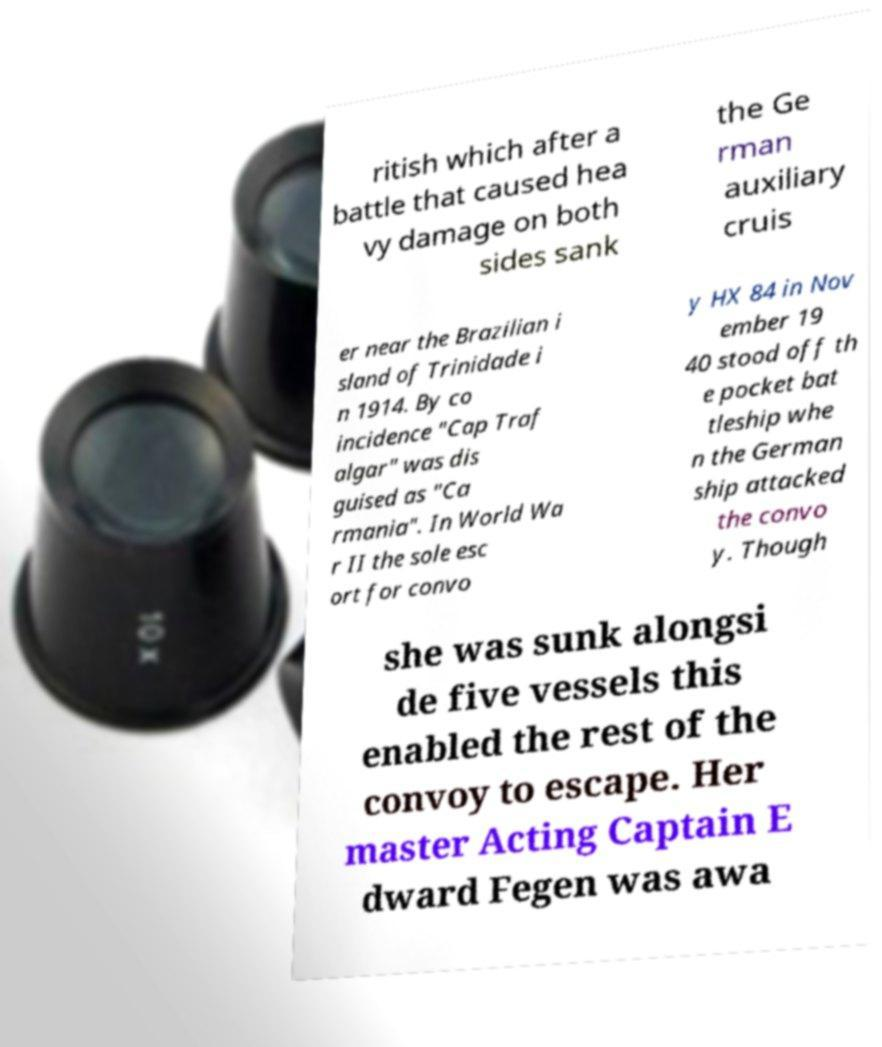Can you accurately transcribe the text from the provided image for me? ritish which after a battle that caused hea vy damage on both sides sank the Ge rman auxiliary cruis er near the Brazilian i sland of Trinidade i n 1914. By co incidence "Cap Traf algar" was dis guised as "Ca rmania". In World Wa r II the sole esc ort for convo y HX 84 in Nov ember 19 40 stood off th e pocket bat tleship whe n the German ship attacked the convo y. Though she was sunk alongsi de five vessels this enabled the rest of the convoy to escape. Her master Acting Captain E dward Fegen was awa 